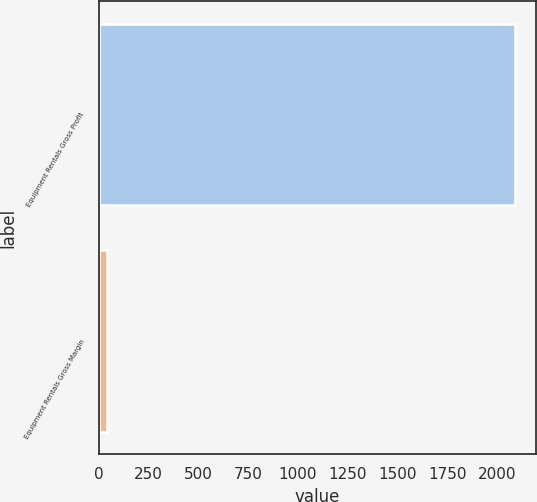Convert chart. <chart><loc_0><loc_0><loc_500><loc_500><bar_chart><fcel>Equipment Rentals Gross Profit<fcel>Equipment Rentals Gross Margin<nl><fcel>2089<fcel>42.3<nl></chart> 